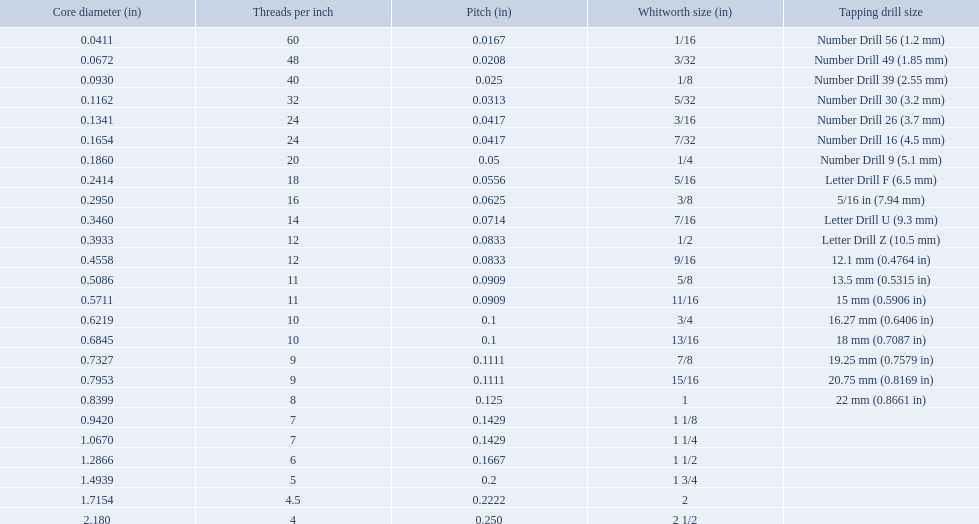What are all of the whitworth sizes? 1/16, 3/32, 1/8, 5/32, 3/16, 7/32, 1/4, 5/16, 3/8, 7/16, 1/2, 9/16, 5/8, 11/16, 3/4, 13/16, 7/8, 15/16, 1, 1 1/8, 1 1/4, 1 1/2, 1 3/4, 2, 2 1/2. How many threads per inch are in each size? 60, 48, 40, 32, 24, 24, 20, 18, 16, 14, 12, 12, 11, 11, 10, 10, 9, 9, 8, 7, 7, 6, 5, 4.5, 4. How many threads per inch are in the 3/16 size? 24. And which other size has the same number of threads? 7/32. 